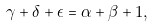Convert formula to latex. <formula><loc_0><loc_0><loc_500><loc_500>\gamma + \delta + \epsilon = \alpha + \beta + 1 ,</formula> 